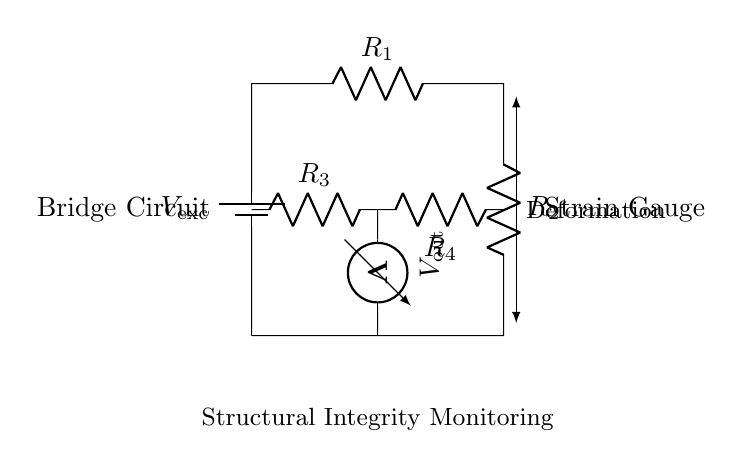What type of circuit is represented in the diagram? The circuit is a bridge circuit, specifically a strain gauge bridge for monitoring structural integrity. This is identified by the arrangement of resistors and the mention of strain gauges.
Answer: bridge circuit What is the function of the voltmeter in this circuit? The voltmeter measures the output voltage across the bridge, which reflects the changes in resistance due to strain on the gauge. Its position and connection in the circuit allow it to capture these voltage variations.
Answer: measure output voltage What are the two resistors labeled R2 and R4 in the diagram? R2 and R4 are part of the strain gauge. They are positioned within the bridge circuit and contribute to the overall resistance that changes with deformation. This setup allows for the measurement of strain as variations in voltage.
Answer: strain gauge resistors How many resistors are there in the circuit? There are four resistors depicted in the bridge circuit, named R1, R2, R3, and R4, which are essential for forming the measurement bridge.
Answer: four What happens when deformation occurs in the structure being monitored? When deformation occurs, the resistance of the strain gauge changes, which in turn alters the voltage output measured by the voltmeter. This allows for the monitoring of structural integrity by translating mechanical strain into measurable electrical signals.
Answer: changes the resistance What is the purpose of the battery in this circuit? The battery provides the excitation voltage necessary to drive current through the circuit, enabling the measurement of resistance changes in the strain gauges. This voltage is crucial for the operation of the bridge circuit.
Answer: provide excitation voltage What is indicated by a change in output voltage across the voltmeter? A change in output voltage indicates a change in strain or deformation within the structure being monitored, which can signify potential structural issues that need addressing.
Answer: indicates structural deformation 